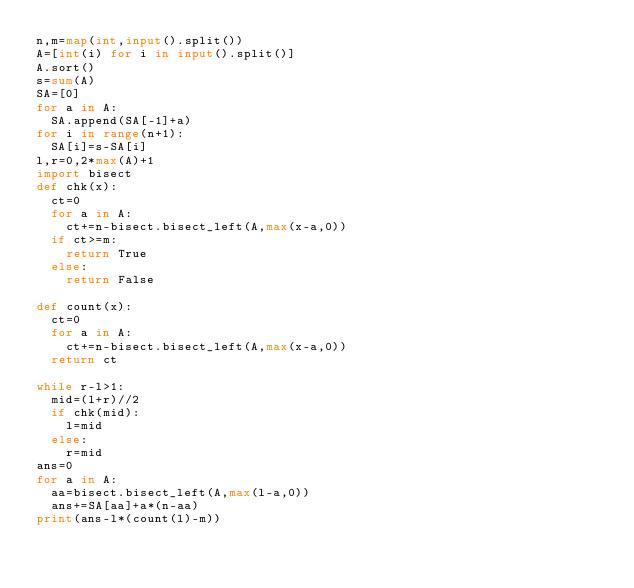Convert code to text. <code><loc_0><loc_0><loc_500><loc_500><_Python_>n,m=map(int,input().split())
A=[int(i) for i in input().split()]
A.sort()
s=sum(A)
SA=[0]
for a in A:
  SA.append(SA[-1]+a)
for i in range(n+1):
  SA[i]=s-SA[i]
l,r=0,2*max(A)+1
import bisect
def chk(x):
  ct=0
  for a in A:
    ct+=n-bisect.bisect_left(A,max(x-a,0))
  if ct>=m:
    return True
  else:
    return False

def count(x):
  ct=0
  for a in A:
    ct+=n-bisect.bisect_left(A,max(x-a,0))
  return ct

while r-l>1:
  mid=(l+r)//2
  if chk(mid):
    l=mid
  else:
    r=mid
ans=0
for a in A:
  aa=bisect.bisect_left(A,max(l-a,0))
  ans+=SA[aa]+a*(n-aa)
print(ans-l*(count(l)-m))
</code> 